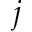Convert formula to latex. <formula><loc_0><loc_0><loc_500><loc_500>j</formula> 